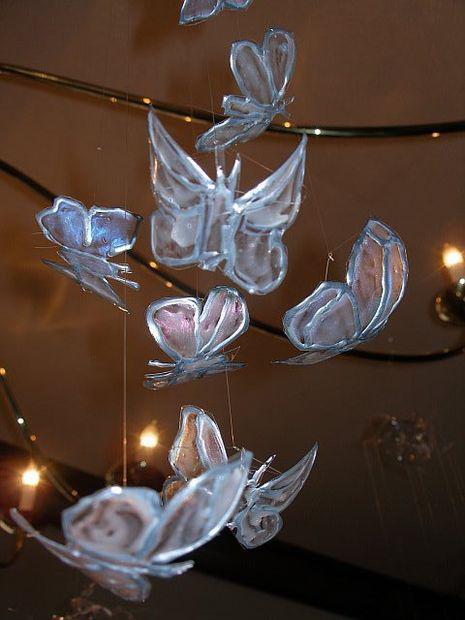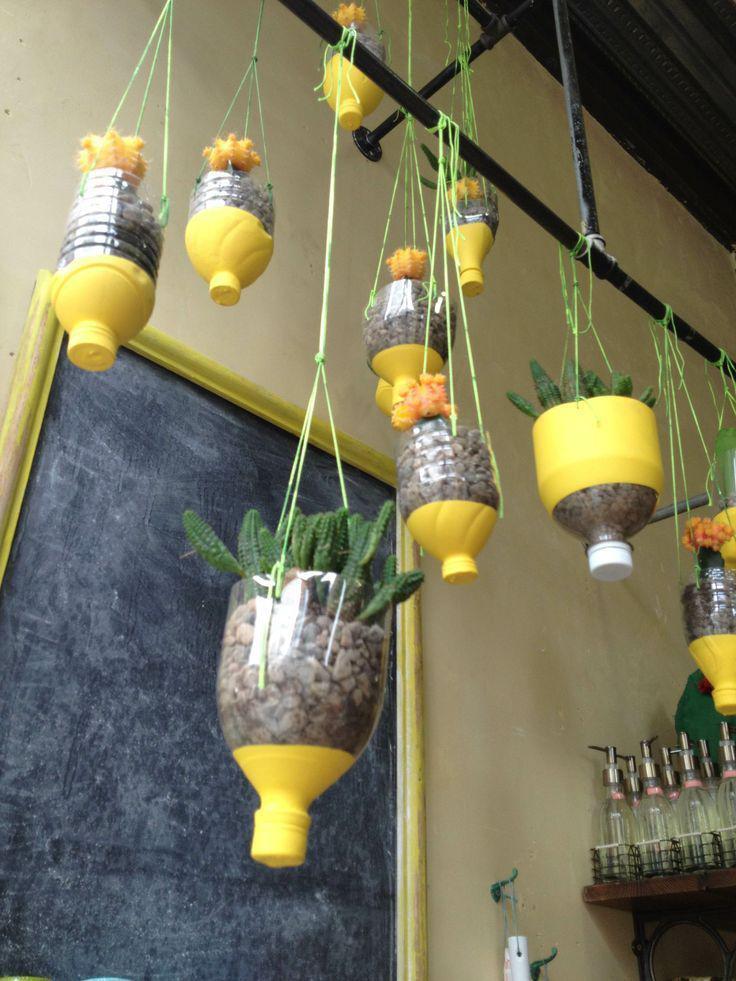The first image is the image on the left, the second image is the image on the right. Given the left and right images, does the statement "In one of the images, there are more than one pots with plantlife in them." hold true? Answer yes or no. Yes. The first image is the image on the left, the second image is the image on the right. Analyze the images presented: Is the assertion "One image shows at leat four faux flowers of different colors, and the other image shows a vase made out of stacked layers of oval shapes that are actually plastic spoons." valid? Answer yes or no. No. 